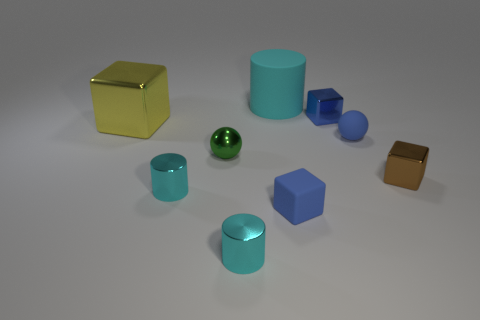Subtract all yellow metallic cubes. How many cubes are left? 3 Add 1 green metal spheres. How many objects exist? 10 Subtract all yellow cylinders. How many blue cubes are left? 2 Subtract all cylinders. How many objects are left? 6 Subtract all yellow cubes. How many cubes are left? 3 Add 6 yellow things. How many yellow things are left? 7 Add 7 cyan matte things. How many cyan matte things exist? 8 Subtract 0 red cylinders. How many objects are left? 9 Subtract all yellow cylinders. Subtract all cyan blocks. How many cylinders are left? 3 Subtract all small green cylinders. Subtract all blue metallic objects. How many objects are left? 8 